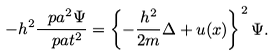Convert formula to latex. <formula><loc_0><loc_0><loc_500><loc_500>- h ^ { 2 } \frac { \ p a ^ { 2 } \Psi } { \ p a t ^ { 2 } } = \left \{ - \frac { h ^ { 2 } } { 2 m } \Delta + u ( x ) \right \} ^ { 2 } \Psi .</formula> 